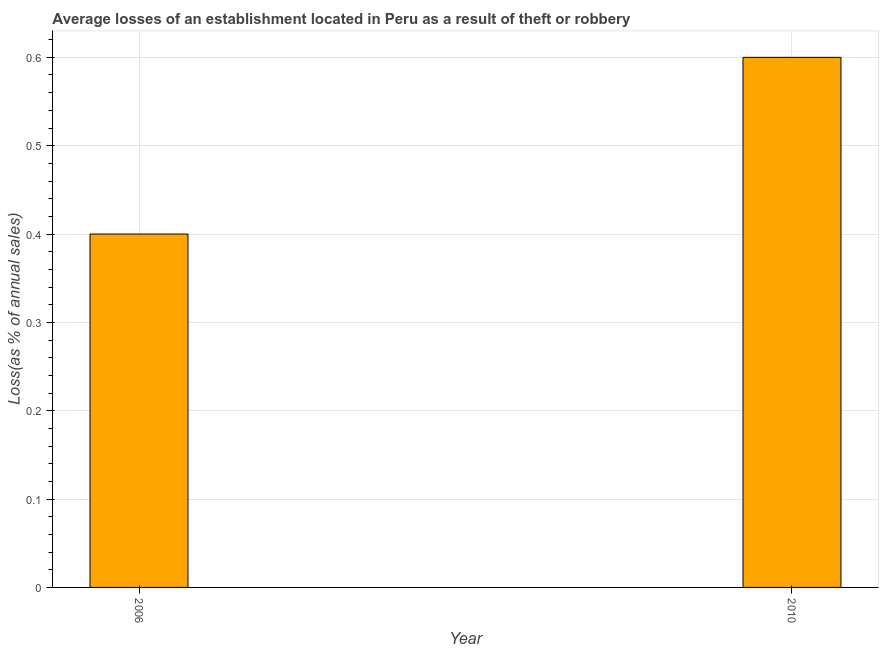What is the title of the graph?
Give a very brief answer. Average losses of an establishment located in Peru as a result of theft or robbery. What is the label or title of the Y-axis?
Your answer should be compact. Loss(as % of annual sales). In which year was the losses due to theft maximum?
Make the answer very short. 2010. In which year was the losses due to theft minimum?
Make the answer very short. 2006. What is the sum of the losses due to theft?
Your answer should be compact. 1. What is the median losses due to theft?
Give a very brief answer. 0.5. Do a majority of the years between 2006 and 2010 (inclusive) have losses due to theft greater than 0.08 %?
Your answer should be very brief. Yes. What is the ratio of the losses due to theft in 2006 to that in 2010?
Keep it short and to the point. 0.67. How many years are there in the graph?
Offer a terse response. 2. What is the difference between two consecutive major ticks on the Y-axis?
Provide a short and direct response. 0.1. What is the Loss(as % of annual sales) of 2006?
Provide a succinct answer. 0.4. What is the ratio of the Loss(as % of annual sales) in 2006 to that in 2010?
Provide a succinct answer. 0.67. 